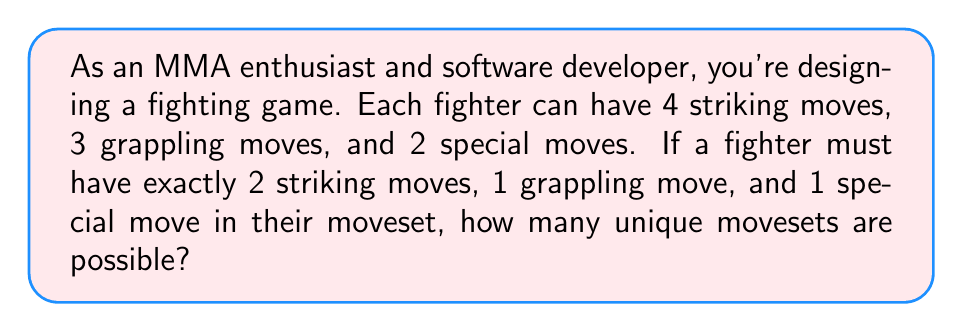Can you answer this question? Let's break this down step-by-step:

1. Striking moves:
   - We need to choose 2 out of 4 striking moves.
   - This can be calculated using the combination formula: $\binom{4}{2}$
   - $\binom{4}{2} = \frac{4!}{2!(4-2)!} = \frac{4 \cdot 3}{2 \cdot 1} = 6$

2. Grappling moves:
   - We need to choose 1 out of 3 grappling moves.
   - This is simply $\binom{3}{1} = 3$

3. Special moves:
   - We need to choose 1 out of 2 special moves.
   - This is $\binom{2}{1} = 2$

4. Total number of possible movesets:
   - We apply the multiplication principle, as each choice is independent.
   - Total combinations = (Striking combinations) × (Grappling combinations) × (Special combinations)
   - $6 \times 3 \times 2 = 36$

Therefore, there are 36 possible unique movesets.
Answer: 36 